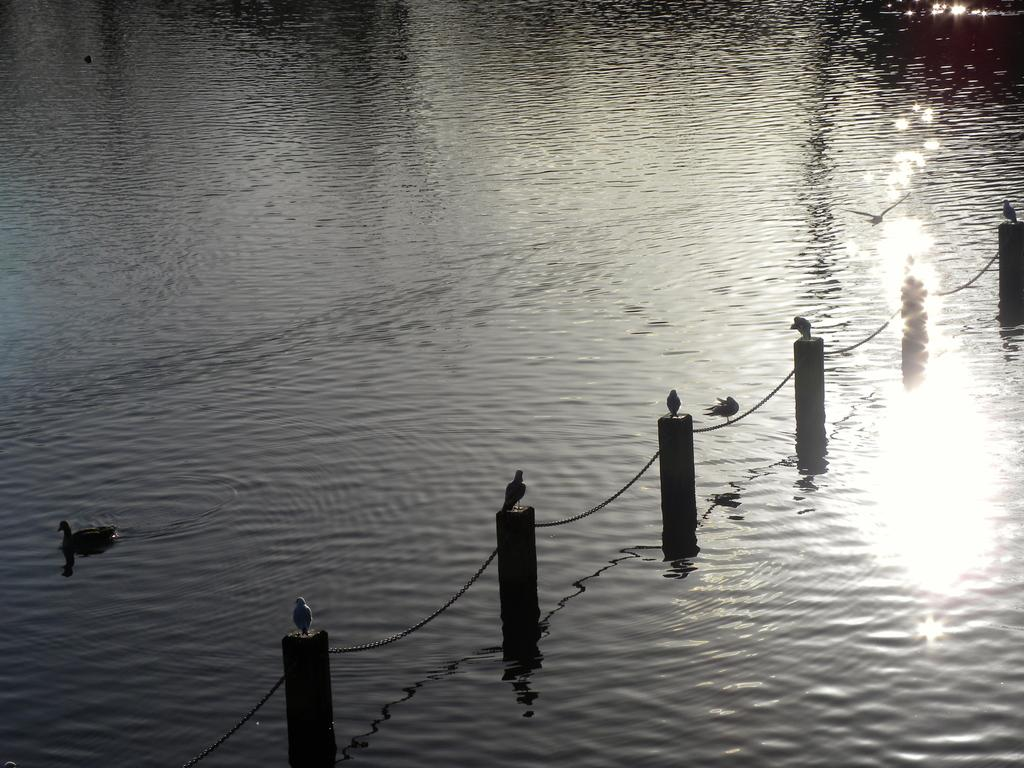What type of animals can be seen in the image? Birds can be seen in the image. What structures are present in the image? There are poles in the image. What is attached to the poles in the image? There is a chain attached to the poles in the image. What is visible in the image besides the poles and chain? There is water visible in the image. What type of holiday is being celebrated in the image? There is no indication of a holiday being celebrated in the image. How much money is visible in the image? There is no money visible in the image. 